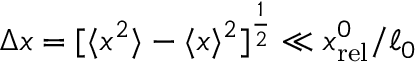<formula> <loc_0><loc_0><loc_500><loc_500>\Delta x = [ \langle x ^ { 2 } \rangle - \langle x \rangle ^ { 2 } ] ^ { \frac { 1 } { 2 } } \ll x _ { r e l } ^ { 0 } / \ell _ { 0 }</formula> 